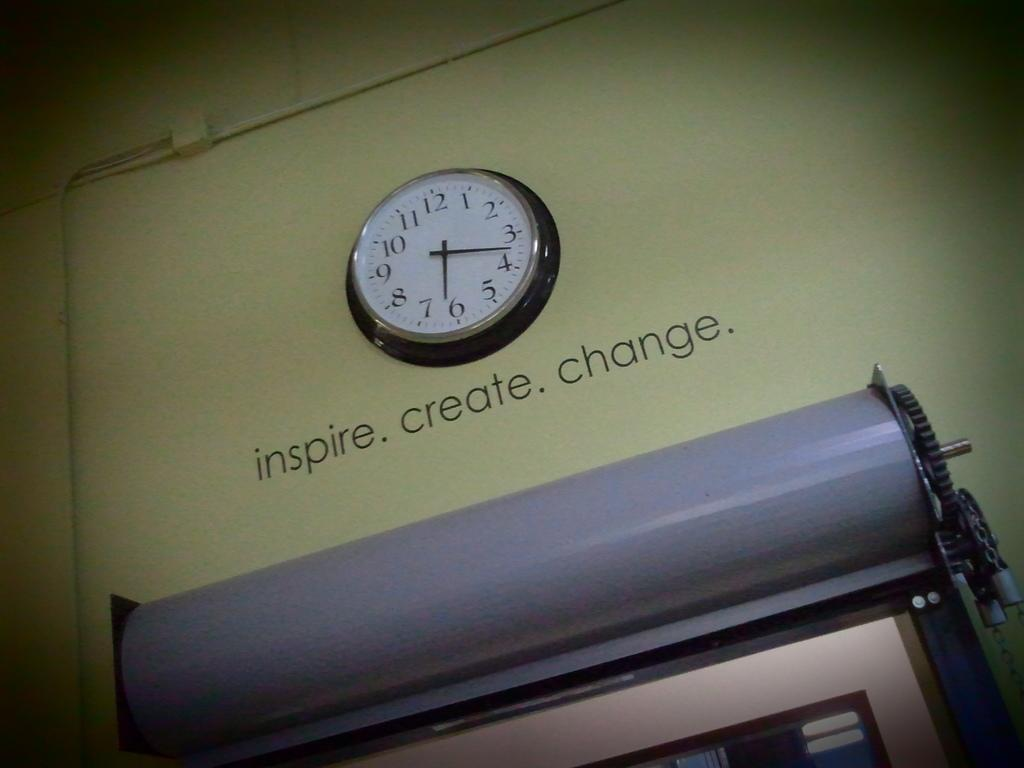<image>
Create a compact narrative representing the image presented. A clock on a wall with the words inspire, create and change below it. 